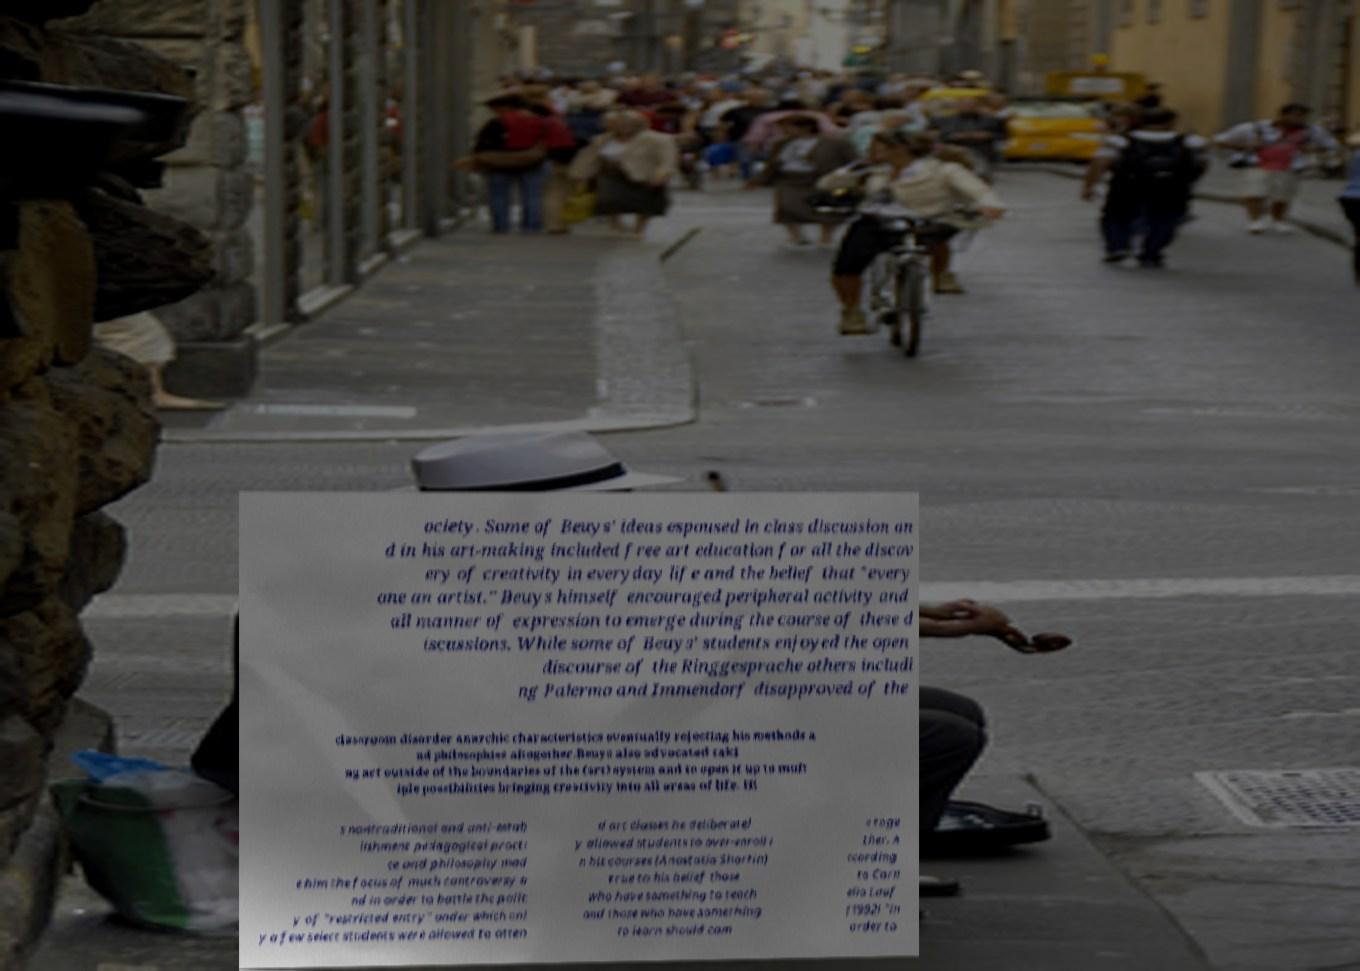What messages or text are displayed in this image? I need them in a readable, typed format. ociety. Some of Beuys' ideas espoused in class discussion an d in his art-making included free art education for all the discov ery of creativity in everyday life and the belief that "every one an artist." Beuys himself encouraged peripheral activity and all manner of expression to emerge during the course of these d iscussions. While some of Beuys' students enjoyed the open discourse of the Ringgesprache others includi ng Palermo and Immendorf disapproved of the classroom disorder anarchic characteristics eventually rejecting his methods a nd philosophies altogether.Beuys also advocated taki ng art outside of the boundaries of the (art) system and to open it up to mult iple possibilities bringing creativity into all areas of life. Hi s nontraditional and anti-estab lishment pedagogical practi ce and philosophy mad e him the focus of much controversy a nd in order to battle the polic y of "restricted entry" under which onl y a few select students were allowed to atten d art classes he deliberatel y allowed students to over-enroll i n his courses (Anastasia Shartin) true to his belief those who have something to teach and those who have something to learn should com e toge ther. A ccording to Corn elia Lauf (1992) "in order to 